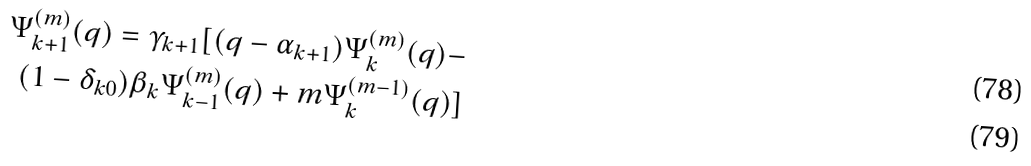Convert formula to latex. <formula><loc_0><loc_0><loc_500><loc_500>\Psi _ { k + 1 } ^ { ( m ) } ( q ) = \gamma _ { k + 1 } [ ( q - \alpha _ { k + 1 } ) \Psi _ { k } ^ { ( m ) } ( q ) - \\ ( 1 - \delta _ { k 0 } ) \beta _ { k } \Psi _ { k - 1 } ^ { ( m ) } ( q ) + m \Psi _ { k } ^ { ( m - 1 ) } ( q ) ]</formula> 